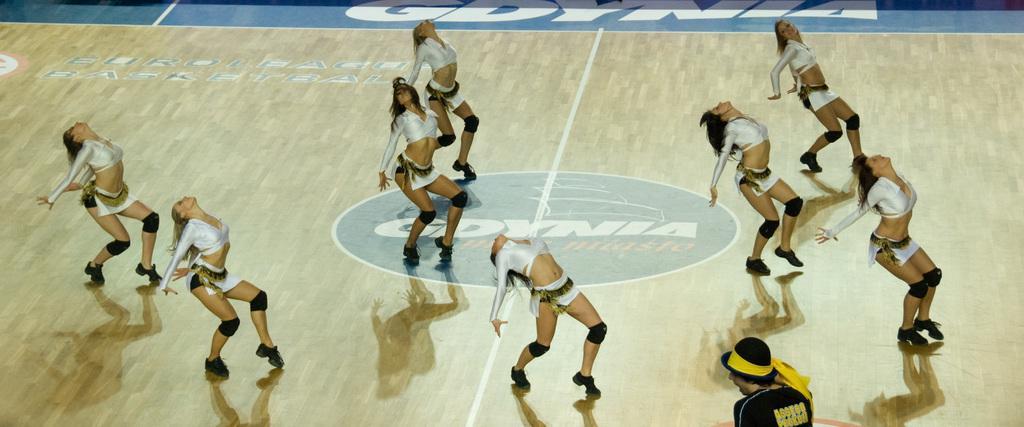Please provide a concise description of this image. In the image there are few cheer girls in white dress dancing on the wooden floor. 